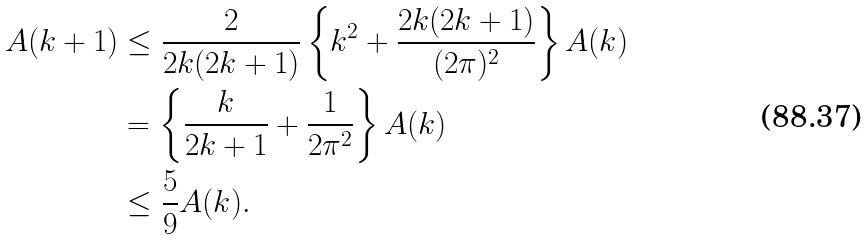<formula> <loc_0><loc_0><loc_500><loc_500>A ( k + 1 ) & \leq \frac { 2 } { 2 k ( 2 k + 1 ) } \left \{ k ^ { 2 } + \frac { 2 k ( 2 k + 1 ) } { ( 2 \pi ) ^ { 2 } } \right \} A ( k ) \\ & = \left \{ \frac { k } { 2 k + 1 } + \frac { 1 } { 2 \pi ^ { 2 } } \right \} A ( k ) \\ & \leq \frac { 5 } { 9 } A ( k ) .</formula> 